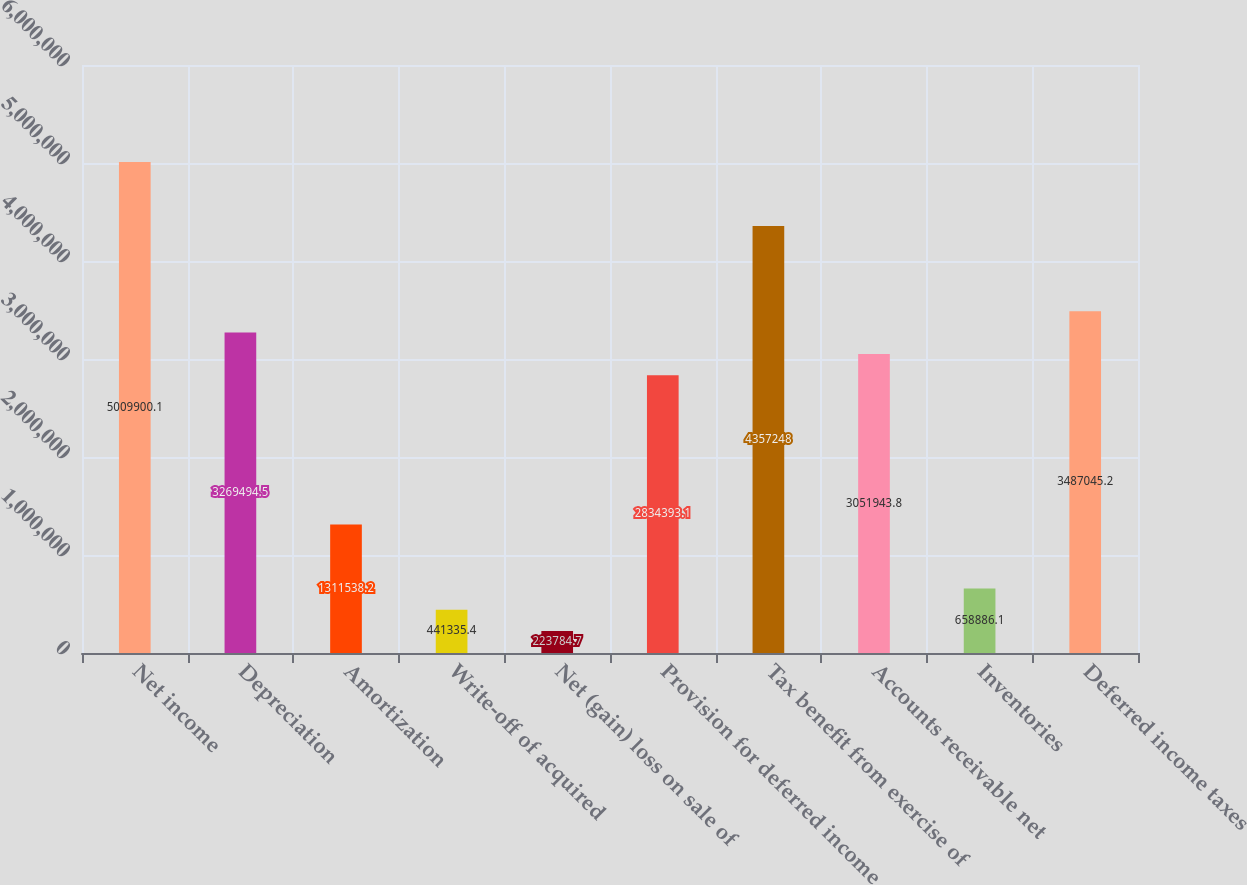Convert chart. <chart><loc_0><loc_0><loc_500><loc_500><bar_chart><fcel>Net income<fcel>Depreciation<fcel>Amortization<fcel>Write-off of acquired<fcel>Net (gain) loss on sale of<fcel>Provision for deferred income<fcel>Tax benefit from exercise of<fcel>Accounts receivable net<fcel>Inventories<fcel>Deferred income taxes<nl><fcel>5.0099e+06<fcel>3.26949e+06<fcel>1.31154e+06<fcel>441335<fcel>223785<fcel>2.83439e+06<fcel>4.35725e+06<fcel>3.05194e+06<fcel>658886<fcel>3.48705e+06<nl></chart> 